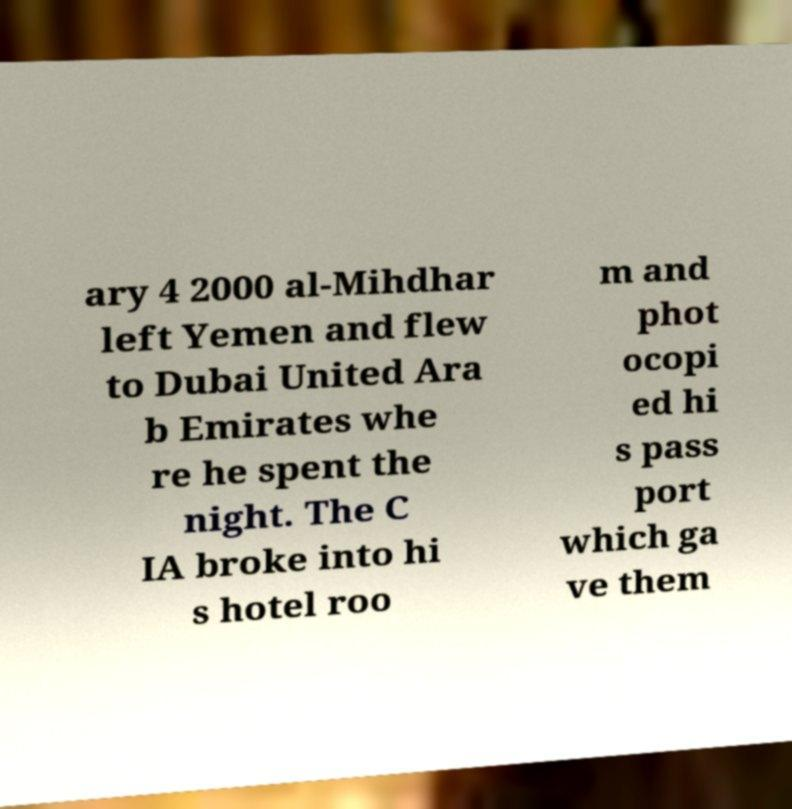Could you assist in decoding the text presented in this image and type it out clearly? ary 4 2000 al-Mihdhar left Yemen and flew to Dubai United Ara b Emirates whe re he spent the night. The C IA broke into hi s hotel roo m and phot ocopi ed hi s pass port which ga ve them 